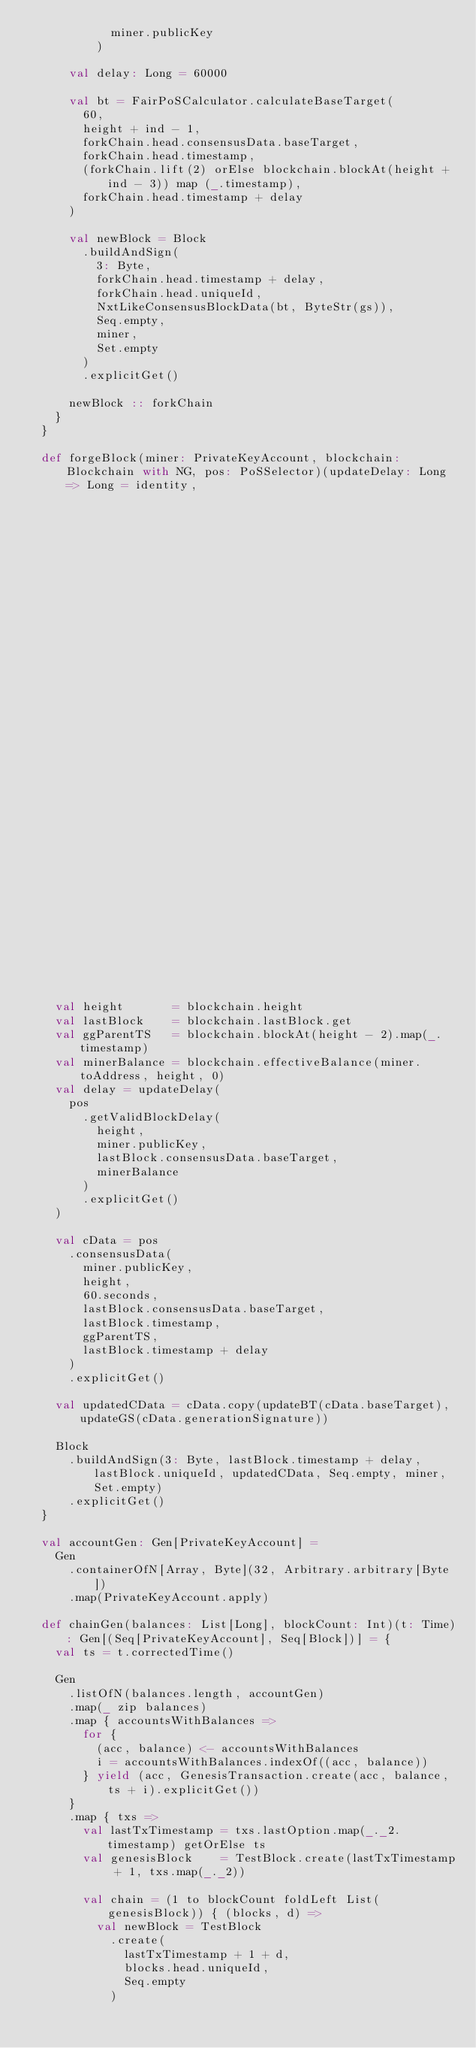<code> <loc_0><loc_0><loc_500><loc_500><_Scala_>            miner.publicKey
          )

      val delay: Long = 60000

      val bt = FairPoSCalculator.calculateBaseTarget(
        60,
        height + ind - 1,
        forkChain.head.consensusData.baseTarget,
        forkChain.head.timestamp,
        (forkChain.lift(2) orElse blockchain.blockAt(height + ind - 3)) map (_.timestamp),
        forkChain.head.timestamp + delay
      )

      val newBlock = Block
        .buildAndSign(
          3: Byte,
          forkChain.head.timestamp + delay,
          forkChain.head.uniqueId,
          NxtLikeConsensusBlockData(bt, ByteStr(gs)),
          Seq.empty,
          miner,
          Set.empty
        )
        .explicitGet()

      newBlock :: forkChain
    }
  }

  def forgeBlock(miner: PrivateKeyAccount, blockchain: Blockchain with NG, pos: PoSSelector)(updateDelay: Long => Long = identity,
                                                                                             updateBT: Long => Long = identity,
                                                                                             updateGS: ByteStr => ByteStr = identity): Block = {
    val height       = blockchain.height
    val lastBlock    = blockchain.lastBlock.get
    val ggParentTS   = blockchain.blockAt(height - 2).map(_.timestamp)
    val minerBalance = blockchain.effectiveBalance(miner.toAddress, height, 0)
    val delay = updateDelay(
      pos
        .getValidBlockDelay(
          height,
          miner.publicKey,
          lastBlock.consensusData.baseTarget,
          minerBalance
        )
        .explicitGet()
    )

    val cData = pos
      .consensusData(
        miner.publicKey,
        height,
        60.seconds,
        lastBlock.consensusData.baseTarget,
        lastBlock.timestamp,
        ggParentTS,
        lastBlock.timestamp + delay
      )
      .explicitGet()

    val updatedCData = cData.copy(updateBT(cData.baseTarget), updateGS(cData.generationSignature))

    Block
      .buildAndSign(3: Byte, lastBlock.timestamp + delay, lastBlock.uniqueId, updatedCData, Seq.empty, miner, Set.empty)
      .explicitGet()
  }

  val accountGen: Gen[PrivateKeyAccount] =
    Gen
      .containerOfN[Array, Byte](32, Arbitrary.arbitrary[Byte])
      .map(PrivateKeyAccount.apply)

  def chainGen(balances: List[Long], blockCount: Int)(t: Time): Gen[(Seq[PrivateKeyAccount], Seq[Block])] = {
    val ts = t.correctedTime()

    Gen
      .listOfN(balances.length, accountGen)
      .map(_ zip balances)
      .map { accountsWithBalances =>
        for {
          (acc, balance) <- accountsWithBalances
          i = accountsWithBalances.indexOf((acc, balance))
        } yield (acc, GenesisTransaction.create(acc, balance, ts + i).explicitGet())
      }
      .map { txs =>
        val lastTxTimestamp = txs.lastOption.map(_._2.timestamp) getOrElse ts
        val genesisBlock    = TestBlock.create(lastTxTimestamp + 1, txs.map(_._2))

        val chain = (1 to blockCount foldLeft List(genesisBlock)) { (blocks, d) =>
          val newBlock = TestBlock
            .create(
              lastTxTimestamp + 1 + d,
              blocks.head.uniqueId,
              Seq.empty
            )</code> 